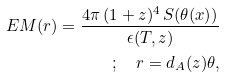Convert formula to latex. <formula><loc_0><loc_0><loc_500><loc_500>E M ( r ) = \frac { 4 \pi \, ( 1 + z ) ^ { 4 } \, S ( \theta ( x ) ) } { \epsilon ( T , z ) } \\ ; \quad r = d _ { A } ( z ) \theta ,</formula> 